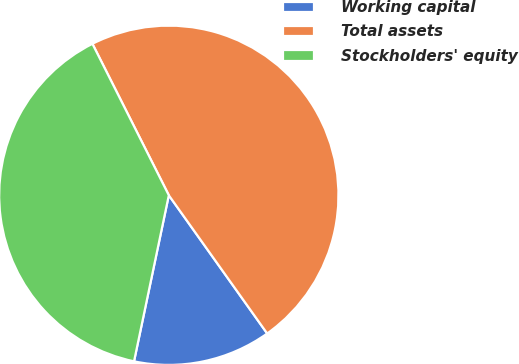<chart> <loc_0><loc_0><loc_500><loc_500><pie_chart><fcel>Working capital<fcel>Total assets<fcel>Stockholders' equity<nl><fcel>13.13%<fcel>47.59%<fcel>39.28%<nl></chart> 